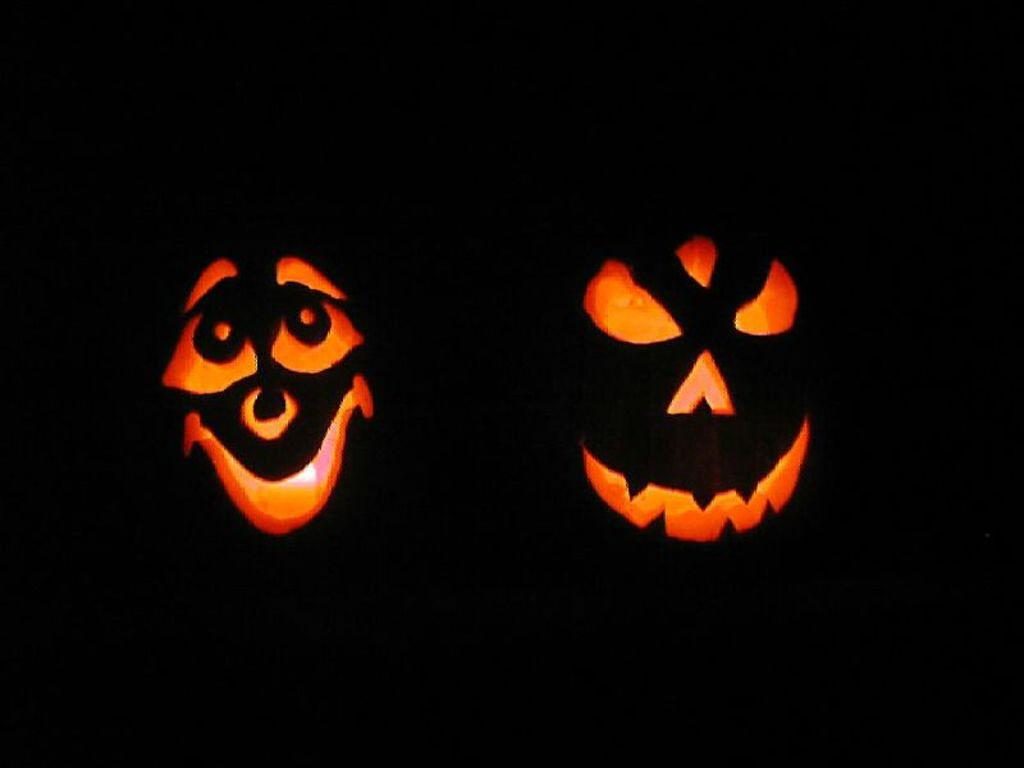What can be observed in the image that is related to Halloween? There are two objects in the image that seem to be related to Halloween. Can you describe the overall lighting or brightness of the image? The image is very dark. What type of brush can be seen in the image? There is no brush present in the image. Is there a baseball bat visible in the image? There is no baseball bat or any reference to baseball in the image. 